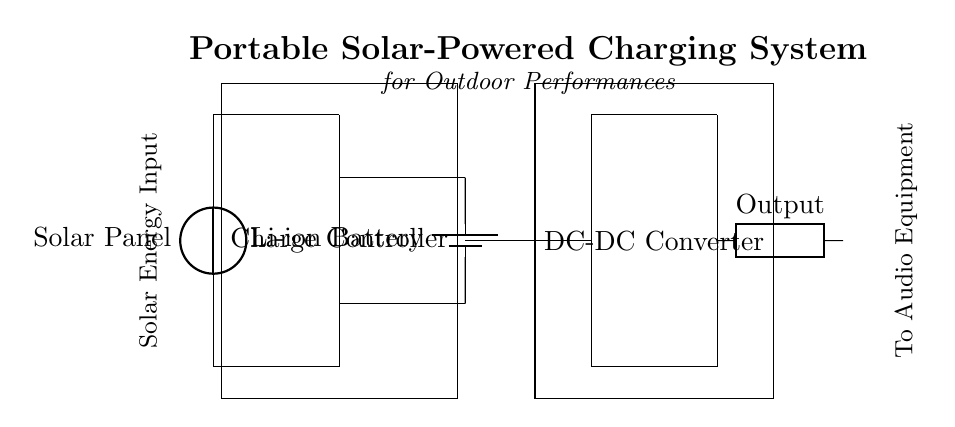What type of energy does this system utilize? The circuit diagram clearly features a solar panel, which converts sunlight into electrical energy. Therefore, the system utilizes solar energy as its primary source.
Answer: Solar energy What component regulates the charging process? The charge controller is depicted in the diagram as a rectangular box between the solar panel and the battery. Its function is to manage the charging process, ensuring that the battery is charged effectively and safely.
Answer: Charge controller How many primary components are in this circuit? By counting the main elements visible in the diagram—solar panel, charge controller, battery, and DC-DC converter—I can confirm that there are four primary components in total.
Answer: Four What is stored in the circuit? The battery is the component responsible for energy storage in the circuit. It is specifically a lithium-ion battery, which is designed to store the electrical energy generated by the solar panel for later use.
Answer: Lithium-ion battery What is the purpose of the DC-DC converter? The DC-DC converter alters the voltage level for the output, allowing the system to provide the appropriate voltage required by external devices. It takes the stored energy from the battery and outputs it for use in audio equipment.
Answer: To adjust voltage What is the output of this system used for? The diagram indicates that the output terminal is labeled 'Output' and connects to audio equipment. This implies that the charged energy from the system is intended to power or charge audio devices used during outdoor performances.
Answer: Audio equipment Which component is responsible for converting sunlight into electricity? The solar panel, located at the top of the diagram, is the part that harnesses sunlight and converts it into electrical energy, which is sent to the charge controller for processing.
Answer: Solar panel 